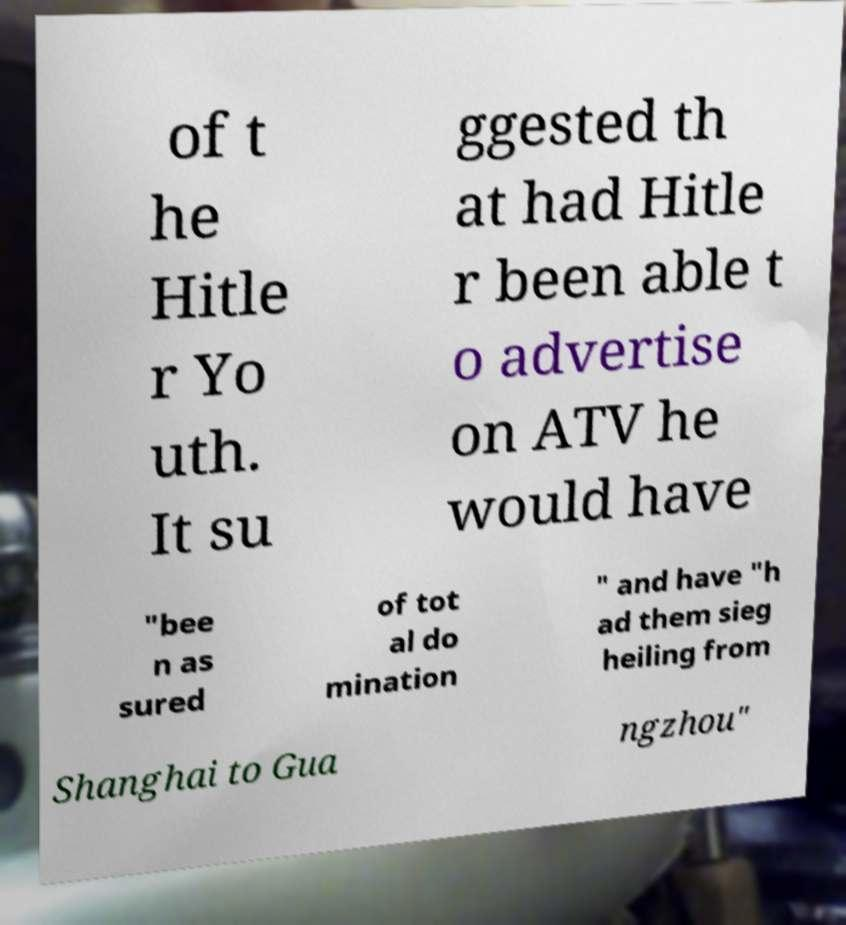For documentation purposes, I need the text within this image transcribed. Could you provide that? of t he Hitle r Yo uth. It su ggested th at had Hitle r been able t o advertise on ATV he would have "bee n as sured of tot al do mination " and have "h ad them sieg heiling from Shanghai to Gua ngzhou" 